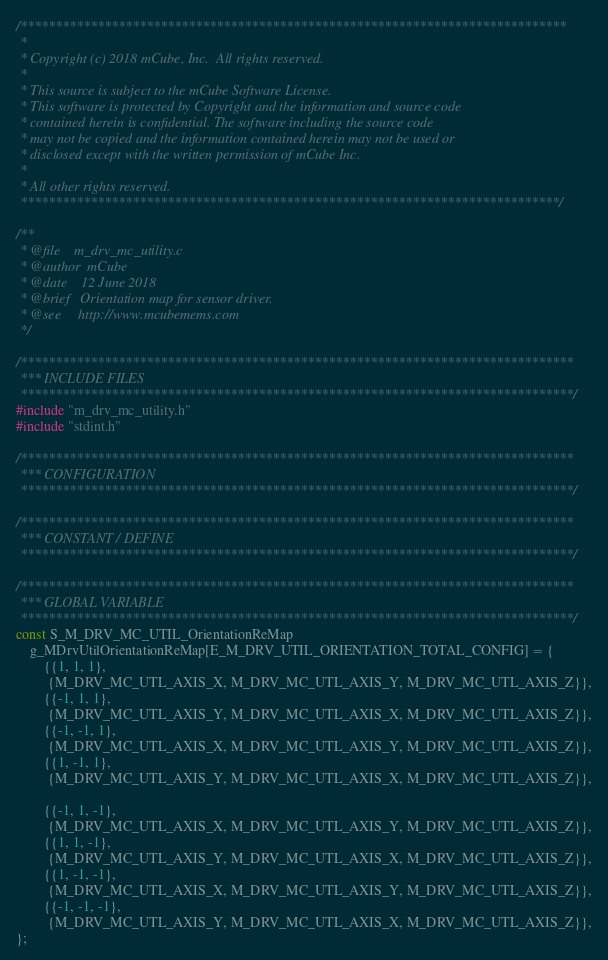Convert code to text. <code><loc_0><loc_0><loc_500><loc_500><_C_>/******************************************************************************
 *
 * Copyright (c) 2018 mCube, Inc.  All rights reserved.
 *
 * This source is subject to the mCube Software License.
 * This software is protected by Copyright and the information and source code
 * contained herein is confidential. The software including the source code
 * may not be copied and the information contained herein may not be used or
 * disclosed except with the written permission of mCube Inc.
 *
 * All other rights reserved.
 *****************************************************************************/

/**
 * @file    m_drv_mc_utility.c
 * @author  mCube
 * @date    12 June 2018
 * @brief   Orientation map for sensor driver.
 * @see     http://www.mcubemems.com
 */

/*******************************************************************************
 *** INCLUDE FILES
 *******************************************************************************/
#include "m_drv_mc_utility.h"
#include "stdint.h"

/*******************************************************************************
 *** CONFIGURATION
 *******************************************************************************/

/*******************************************************************************
 *** CONSTANT / DEFINE
 *******************************************************************************/

/*******************************************************************************
 *** GLOBAL VARIABLE
 *******************************************************************************/
const S_M_DRV_MC_UTIL_OrientationReMap
    g_MDrvUtilOrientationReMap[E_M_DRV_UTIL_ORIENTATION_TOTAL_CONFIG] = {
        {{1, 1, 1},
         {M_DRV_MC_UTL_AXIS_X, M_DRV_MC_UTL_AXIS_Y, M_DRV_MC_UTL_AXIS_Z}},
        {{-1, 1, 1},
         {M_DRV_MC_UTL_AXIS_Y, M_DRV_MC_UTL_AXIS_X, M_DRV_MC_UTL_AXIS_Z}},
        {{-1, -1, 1},
         {M_DRV_MC_UTL_AXIS_X, M_DRV_MC_UTL_AXIS_Y, M_DRV_MC_UTL_AXIS_Z}},
        {{1, -1, 1},
         {M_DRV_MC_UTL_AXIS_Y, M_DRV_MC_UTL_AXIS_X, M_DRV_MC_UTL_AXIS_Z}},

        {{-1, 1, -1},
         {M_DRV_MC_UTL_AXIS_X, M_DRV_MC_UTL_AXIS_Y, M_DRV_MC_UTL_AXIS_Z}},
        {{1, 1, -1},
         {M_DRV_MC_UTL_AXIS_Y, M_DRV_MC_UTL_AXIS_X, M_DRV_MC_UTL_AXIS_Z}},
        {{1, -1, -1},
         {M_DRV_MC_UTL_AXIS_X, M_DRV_MC_UTL_AXIS_Y, M_DRV_MC_UTL_AXIS_Z}},
        {{-1, -1, -1},
         {M_DRV_MC_UTL_AXIS_Y, M_DRV_MC_UTL_AXIS_X, M_DRV_MC_UTL_AXIS_Z}},
};
</code> 